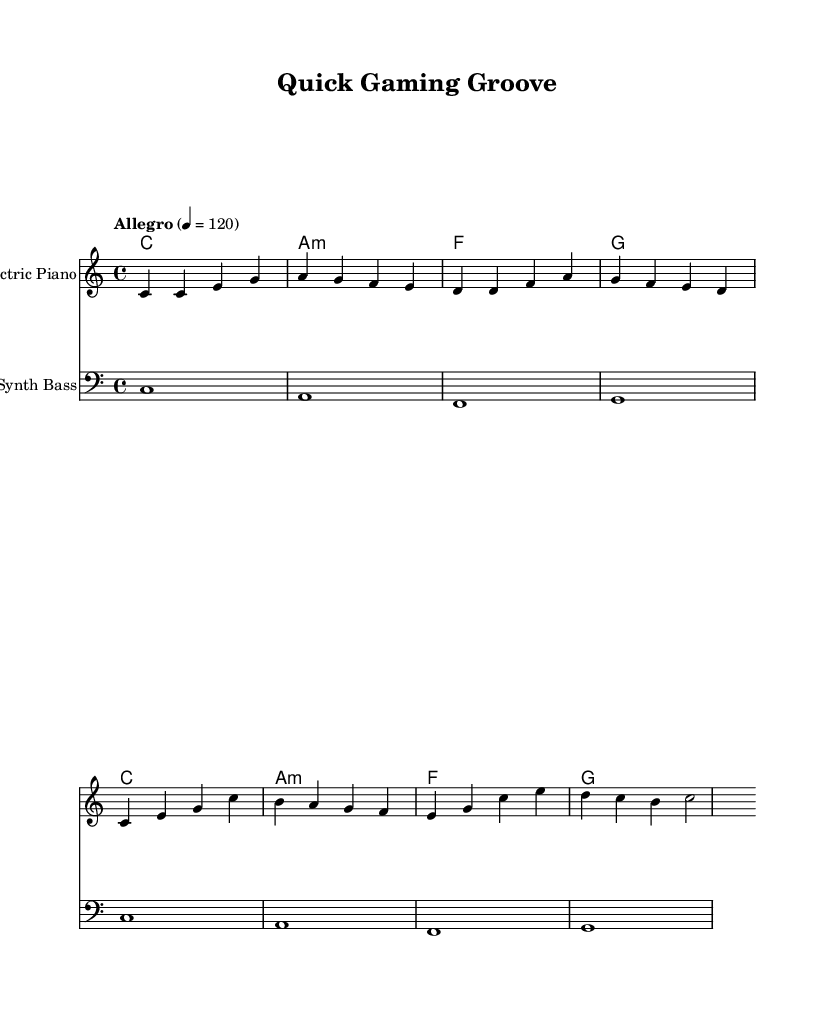What is the key signature of this music? The key signature is C major, indicated by the absence of sharps or flats. You can identify the key signature by looking at the beginning of the staff, where there are no accidentals present.
Answer: C major What is the time signature of this music? The time signature is 4/4, which indicates that there are four beats in each measure and a quarter note receives one beat. This information is located at the beginning of the score before the first note.
Answer: 4/4 What is the tempo marking of this piece? The tempo marking indicates "Allegro" with a metronome mark of 120 beats per minute. This is stated at the beginning of the score, showing the intended speed of the piece.
Answer: Allegro 4 = 120 How many measures are in the melody section? To find the number of measures, count the groups of notes separated by vertical lines (bars). There are a total of 8 measures in the melody section based on the grouping of notes.
Answer: 8 What type of chords are used in the harmonies section? The harmonies consist of major and minor chords, specifically C major, A minor, F major, and G major. This can be deduced from the chord names labeled above the melody line.
Answer: Major and Minor What instrument plays the melody in this score? The melody is designated for the "Electric Piano," which is specified above the staff where the melody is notated. This indicates which instrument is to perform the melodic line.
Answer: Electric Piano Which section has a bass clef? The bass section of the score is indicated with a bass clef symbol, which is positioned at the beginning of that staff line. It tells the musician to play the lower notes typically found in bass lines.
Answer: Bass 